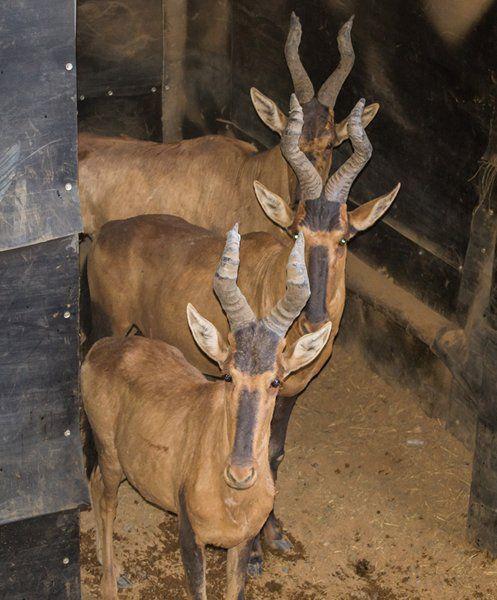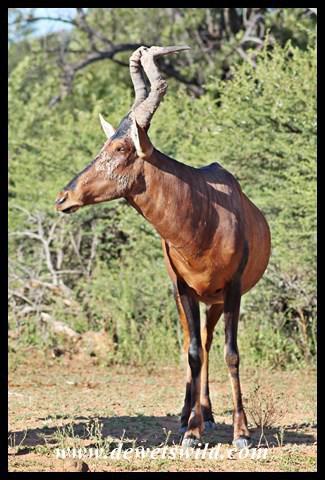The first image is the image on the left, the second image is the image on the right. Analyze the images presented: Is the assertion "One image contains one horned animal standing with its body aimed rightward and its face turned forwards, and the other image includes a horned animal with its rear to the camera." valid? Answer yes or no. No. The first image is the image on the left, the second image is the image on the right. Given the left and right images, does the statement "The left and right image contains the same number of elk." hold true? Answer yes or no. No. 